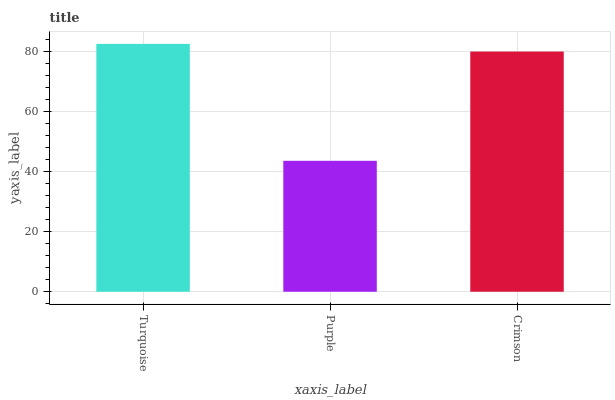Is Purple the minimum?
Answer yes or no. Yes. Is Turquoise the maximum?
Answer yes or no. Yes. Is Crimson the minimum?
Answer yes or no. No. Is Crimson the maximum?
Answer yes or no. No. Is Crimson greater than Purple?
Answer yes or no. Yes. Is Purple less than Crimson?
Answer yes or no. Yes. Is Purple greater than Crimson?
Answer yes or no. No. Is Crimson less than Purple?
Answer yes or no. No. Is Crimson the high median?
Answer yes or no. Yes. Is Crimson the low median?
Answer yes or no. Yes. Is Purple the high median?
Answer yes or no. No. Is Turquoise the low median?
Answer yes or no. No. 